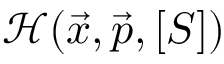Convert formula to latex. <formula><loc_0><loc_0><loc_500><loc_500>\mathcal { H } ( \vec { x } , \vec { p } , [ S ] )</formula> 